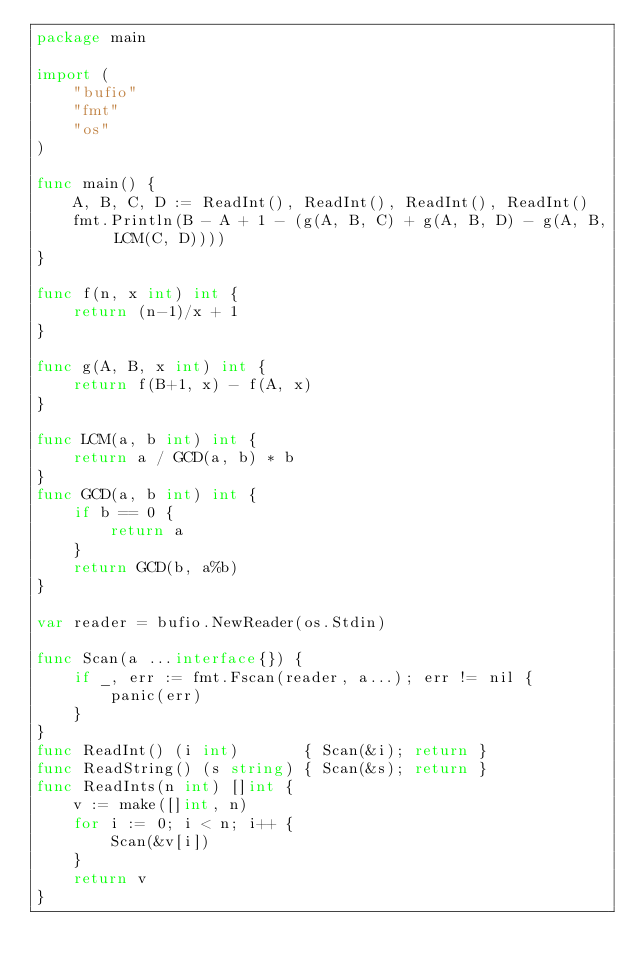Convert code to text. <code><loc_0><loc_0><loc_500><loc_500><_Go_>package main

import (
	"bufio"
	"fmt"
	"os"
)

func main() {
	A, B, C, D := ReadInt(), ReadInt(), ReadInt(), ReadInt()
	fmt.Println(B - A + 1 - (g(A, B, C) + g(A, B, D) - g(A, B, LCM(C, D))))
}

func f(n, x int) int {
	return (n-1)/x + 1
}

func g(A, B, x int) int {
	return f(B+1, x) - f(A, x)
}

func LCM(a, b int) int {
	return a / GCD(a, b) * b
}
func GCD(a, b int) int {
	if b == 0 {
		return a
	}
	return GCD(b, a%b)
}

var reader = bufio.NewReader(os.Stdin)

func Scan(a ...interface{}) {
	if _, err := fmt.Fscan(reader, a...); err != nil {
		panic(err)
	}
}
func ReadInt() (i int)       { Scan(&i); return }
func ReadString() (s string) { Scan(&s); return }
func ReadInts(n int) []int {
	v := make([]int, n)
	for i := 0; i < n; i++ {
		Scan(&v[i])
	}
	return v
}
</code> 